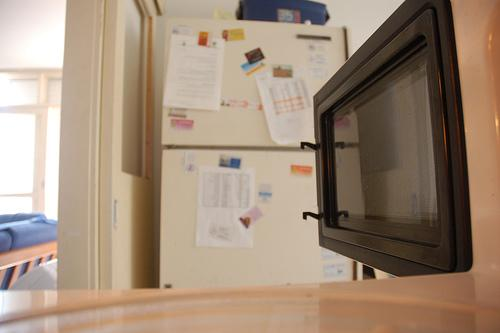What is the main appliance mentioned in the image? A refrigerator. Can you find a piece of furniture in the image? If so, describe it. Yes, a couch with a wood frame and blue cushions. Count the objects related to the refrigerator. 11 objects - refrigerator, magnets, paper, freezer, beige sliding door, box, beige fridge, papers, two-door fridge, lots of magnets, blue container. List all the colors that can be found in the image. Beige, black, blue, white, and orange. How many different refrigerator descriptions are provided in the image? Six - a refrigerator, beige colored refrigerator, freezer portion, beige sliding door, two-door refrigerator, beige fridge. What is the predominant sentiment in the image? Neutral, as it is a depiction of various objects in a kitchen. What kind of paper is mentioned in the image? A white paper with orange highlights attached to the refrigerator by a magnet. Describe the object on top of the refrigerator. A blue plastic tub and a blue container. Identify and describe the state of the door of the microwave. The black microwave door is open with a glass window. How many objects can be found inside the microwave? Five - the inside of the microwave, white insides, glass dish, round plate, and microwave tray. Give an example of an object that is related to cooking or heating food in this image. inside of the microwave door How visually appealing is the image? average quality and ordinary scene Describe the main objects in the image. a refrigerator, an open microwave, a couch with blue cushions, a piece of paper with highlighted text, and various magnets Count the number of cushions on the couch. Not visible, only blue cushions can be seen. Which object is referred to as 'the beige sliding door'? the beige colored refrigerator in the kitchen What is the mood conveyed by this image? neutral or everyday setting What is the purpose of the hooks near the microwave door? to lock the door when it is closed Describe the relationship between the microwave and its door. The microwave door is open, revealing its interior. What is the color and material of the couch? blue cushions, and wooden frame Which object is larger: the microwave tray or the refrigerator freezer portion? the microwave tray What is the color of the refrigerator? beige Identify the interaction between the magnet and paper on the refrigerator. the magnet is holding the paper on the refrigerator Do you see a stack of books on the floor beside the couch? Describe the books and their arrangement. There is a stack of books beside the couch, describe the books and their arrangement. Could you tell me if there is a cat resting on the couch, and if so, what color is it? There is a cat resting on the couch, determine its color. Read any visible text on the paper in the image. Text not visible, only orange highlights can be seen Can you identify a clock on the wall near the refrigerator and describe its design? There is a clock on the wall near the refrigerator, describe the clock's design and features. Can you spot a red vase on the kitchen counter and describe its size and shape? Find the red vase on the kitchen counter and provide details about its size and shape. Is there any unusual or unexpected object in the image? No, all objects are common in a household setting. Are there any plants in the room, and if so, identify the type of plant and its position? There are some plants in the room, identify their types and positions. Is there any object attached to the refrigerator? Yes, a piece of paper is attached to the fridge. Describe the position of the blue cushions with respect to the couch. The blue cushions are placed on the couch Findan object on top of the refrigerator and describe it. a blue plastic tub What is the shape of the glass dish? The shape is not visible, only its size corresponds with being round. Please find the location of the framed picture hanging on the wall next to the refrigerator, and describe its content. There is a framed picture hanging on the wall next to the refrigerator, describe what is in the picture. 